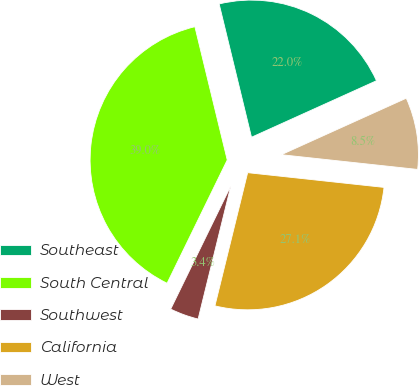Convert chart. <chart><loc_0><loc_0><loc_500><loc_500><pie_chart><fcel>Southeast<fcel>South Central<fcel>Southwest<fcel>California<fcel>West<nl><fcel>22.03%<fcel>38.98%<fcel>3.39%<fcel>27.12%<fcel>8.47%<nl></chart> 